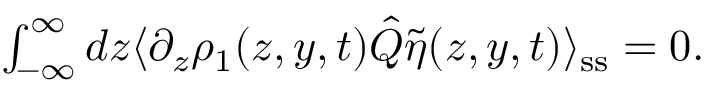Convert formula to latex. <formula><loc_0><loc_0><loc_500><loc_500>\begin{array} { r } { \int _ { - \infty } ^ { \infty } d z \langle \partial _ { z } \rho _ { 1 } ( z , y , t ) \hat { Q } \tilde { \eta } ( z , y , t ) \rangle _ { s s } = 0 . } \end{array}</formula> 